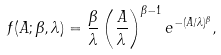Convert formula to latex. <formula><loc_0><loc_0><loc_500><loc_500>f ( A ; \beta , \lambda ) = \frac { \beta } { \lambda } \left ( \frac { A } { \lambda } \right ) ^ { \beta - 1 } e ^ { - ( { A } / { \lambda } ) ^ { \beta } } ,</formula> 